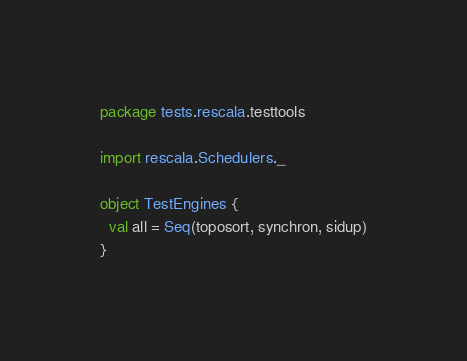Convert code to text. <code><loc_0><loc_0><loc_500><loc_500><_Scala_>package tests.rescala.testtools

import rescala.Schedulers._

object TestEngines {
  val all = Seq(toposort, synchron, sidup)
}
</code> 